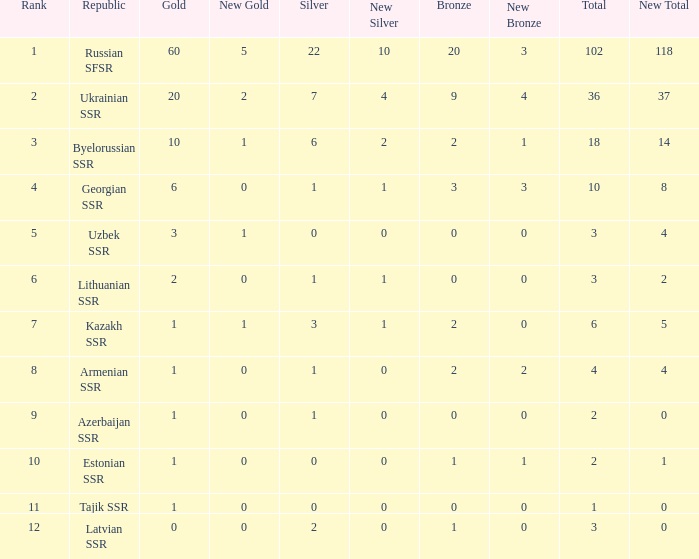What is the average total for teams with more than 1 gold, ranked over 3 and more than 3 bronze? None. I'm looking to parse the entire table for insights. Could you assist me with that? {'header': ['Rank', 'Republic', 'Gold', 'New Gold', 'Silver', 'New Silver', 'Bronze', 'New Bronze', 'Total', 'New Total'], 'rows': [['1', 'Russian SFSR', '60', '5', '22', '10', '20', '3', '102', '118'], ['2', 'Ukrainian SSR', '20', '2', '7', '4', '9', '4', '36', '37'], ['3', 'Byelorussian SSR', '10', '1', '6', '2', '2', '1', '18', '14'], ['4', 'Georgian SSR', '6', '0', '1', '1', '3', '3', '10', '8'], ['5', 'Uzbek SSR', '3', '1', '0', '0', '0', '0', '3', '4'], ['6', 'Lithuanian SSR', '2', '0', '1', '1', '0', '0', '3', '2'], ['7', 'Kazakh SSR', '1', '1', '3', '1', '2', '0', '6', '5'], ['8', 'Armenian SSR', '1', '0', '1', '0', '2', '2', '4', '4'], ['9', 'Azerbaijan SSR', '1', '0', '1', '0', '0', '0', '2', '0'], ['10', 'Estonian SSR', '1', '0', '0', '0', '1', '1', '2', '1'], ['11', 'Tajik SSR', '1', '0', '0', '0', '0', '0', '1', '0'], ['12', 'Latvian SSR', '0', '0', '2', '0', '1', '0', '3', '0']]} 